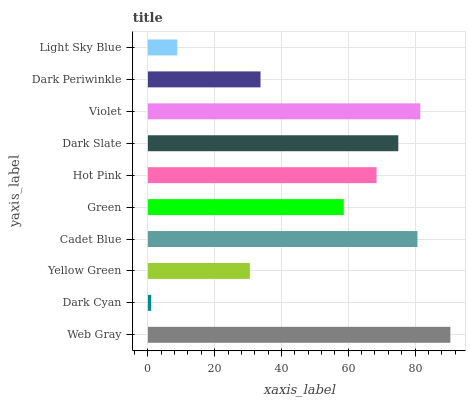Is Dark Cyan the minimum?
Answer yes or no. Yes. Is Web Gray the maximum?
Answer yes or no. Yes. Is Yellow Green the minimum?
Answer yes or no. No. Is Yellow Green the maximum?
Answer yes or no. No. Is Yellow Green greater than Dark Cyan?
Answer yes or no. Yes. Is Dark Cyan less than Yellow Green?
Answer yes or no. Yes. Is Dark Cyan greater than Yellow Green?
Answer yes or no. No. Is Yellow Green less than Dark Cyan?
Answer yes or no. No. Is Hot Pink the high median?
Answer yes or no. Yes. Is Green the low median?
Answer yes or no. Yes. Is Yellow Green the high median?
Answer yes or no. No. Is Web Gray the low median?
Answer yes or no. No. 